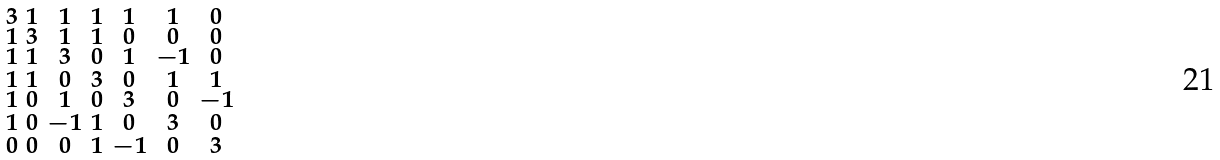Convert formula to latex. <formula><loc_0><loc_0><loc_500><loc_500>\begin{smallmatrix} 3 & 1 & 1 & 1 & 1 & 1 & 0 \\ 1 & 3 & 1 & 1 & 0 & 0 & 0 \\ 1 & 1 & 3 & 0 & 1 & - 1 & 0 \\ 1 & 1 & 0 & 3 & 0 & 1 & 1 \\ 1 & 0 & 1 & 0 & 3 & 0 & - 1 \\ 1 & 0 & - 1 & 1 & 0 & 3 & 0 \\ 0 & 0 & 0 & 1 & - 1 & 0 & 3 \end{smallmatrix}</formula> 